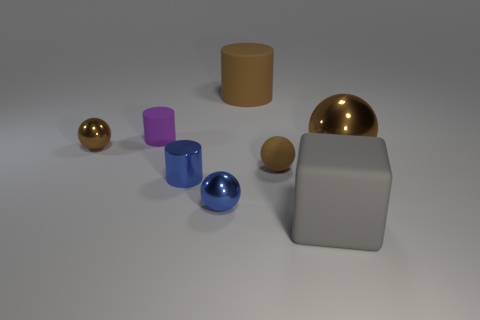What material is the brown ball in front of the metallic thing that is on the right side of the tiny rubber ball?
Keep it short and to the point. Rubber. How many things are either brown metal spheres that are right of the small rubber sphere or balls left of the big brown metal object?
Provide a short and direct response. 4. There is a metallic ball that is left of the cylinder in front of the brown shiny object on the right side of the big gray block; what is its size?
Provide a short and direct response. Small. Is the number of tiny cylinders that are on the right side of the tiny brown rubber ball the same as the number of green rubber spheres?
Ensure brevity in your answer.  Yes. Is there anything else that is the same shape as the small brown matte object?
Give a very brief answer. Yes. Is the shape of the tiny brown metallic thing the same as the large thing in front of the large metal sphere?
Provide a succinct answer. No. What is the size of the blue shiny thing that is the same shape as the tiny brown metal object?
Ensure brevity in your answer.  Small. How many other things are there of the same material as the blue sphere?
Your answer should be very brief. 3. What material is the blue cylinder?
Make the answer very short. Metal. There is a large matte thing behind the big metallic thing; is its color the same as the metal thing to the left of the small blue shiny cylinder?
Offer a terse response. Yes. 